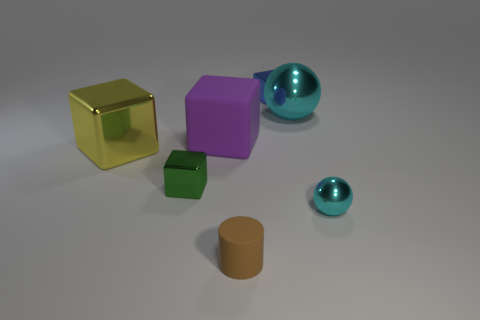The big metal thing that is the same color as the tiny metal sphere is what shape?
Give a very brief answer. Sphere. How many tiny objects are cyan metal things or matte cylinders?
Make the answer very short. 2. What is the size of the green metal object?
Ensure brevity in your answer.  Small. There is a green metallic object; what shape is it?
Provide a short and direct response. Cube. Is there any other thing that is the same shape as the small brown matte thing?
Offer a very short reply. No. Are there fewer things in front of the big yellow thing than tiny spheres?
Offer a very short reply. No. There is a sphere that is in front of the large purple matte cube; does it have the same color as the big shiny ball?
Provide a short and direct response. Yes. What number of metal objects are green cylinders or cyan objects?
Provide a short and direct response. 2. What color is the large ball that is the same material as the blue object?
Provide a short and direct response. Cyan. What number of cubes are tiny metallic things or big yellow things?
Give a very brief answer. 3. 